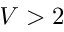Convert formula to latex. <formula><loc_0><loc_0><loc_500><loc_500>V > 2</formula> 